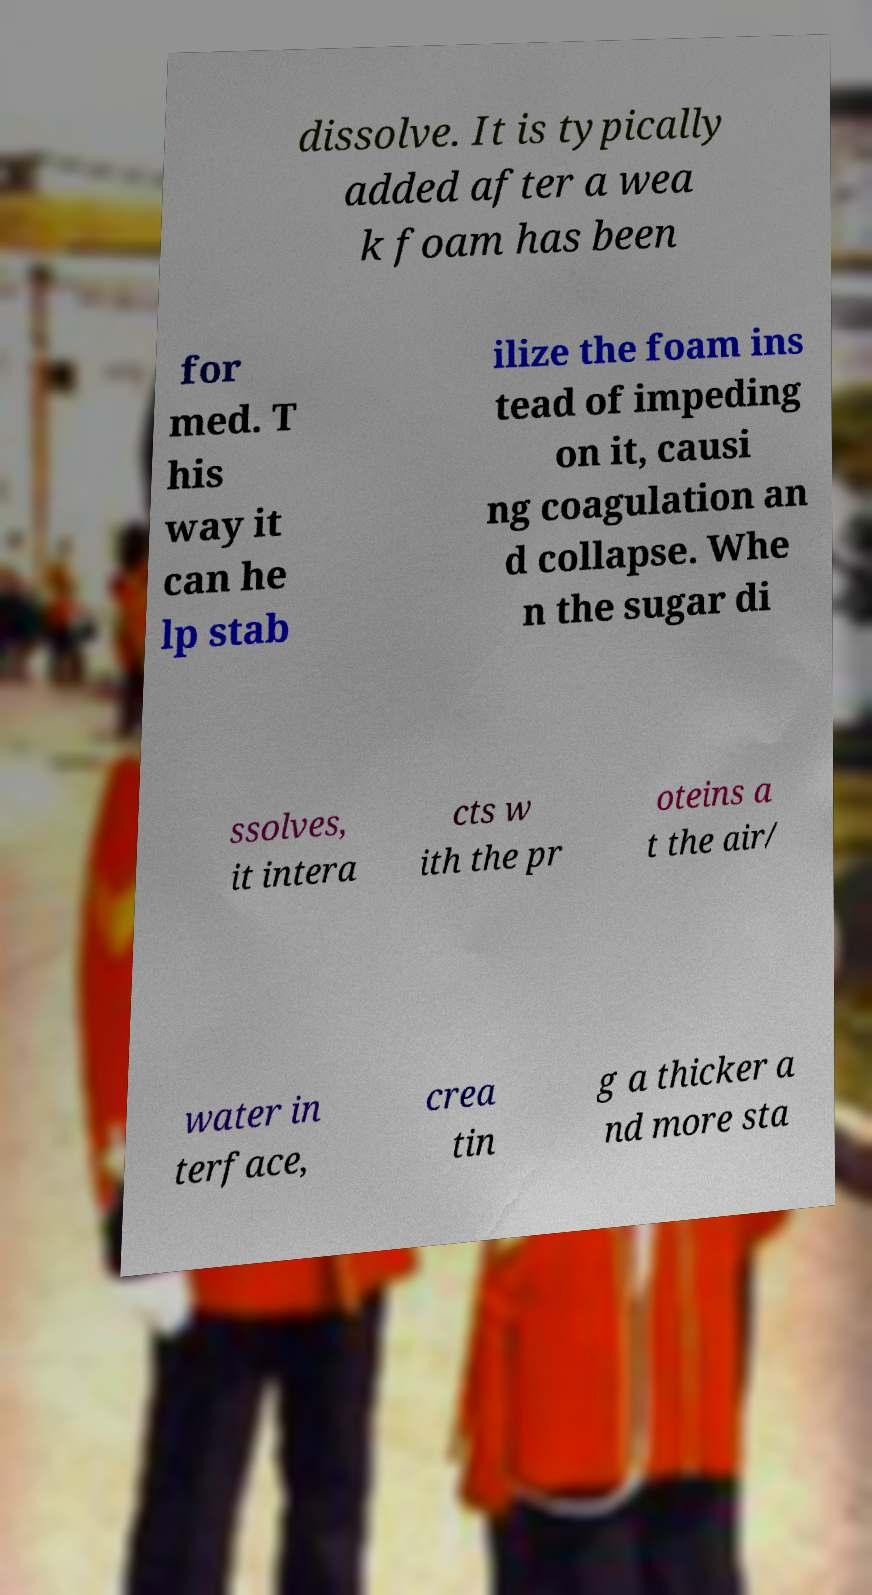There's text embedded in this image that I need extracted. Can you transcribe it verbatim? dissolve. It is typically added after a wea k foam has been for med. T his way it can he lp stab ilize the foam ins tead of impeding on it, causi ng coagulation an d collapse. Whe n the sugar di ssolves, it intera cts w ith the pr oteins a t the air/ water in terface, crea tin g a thicker a nd more sta 